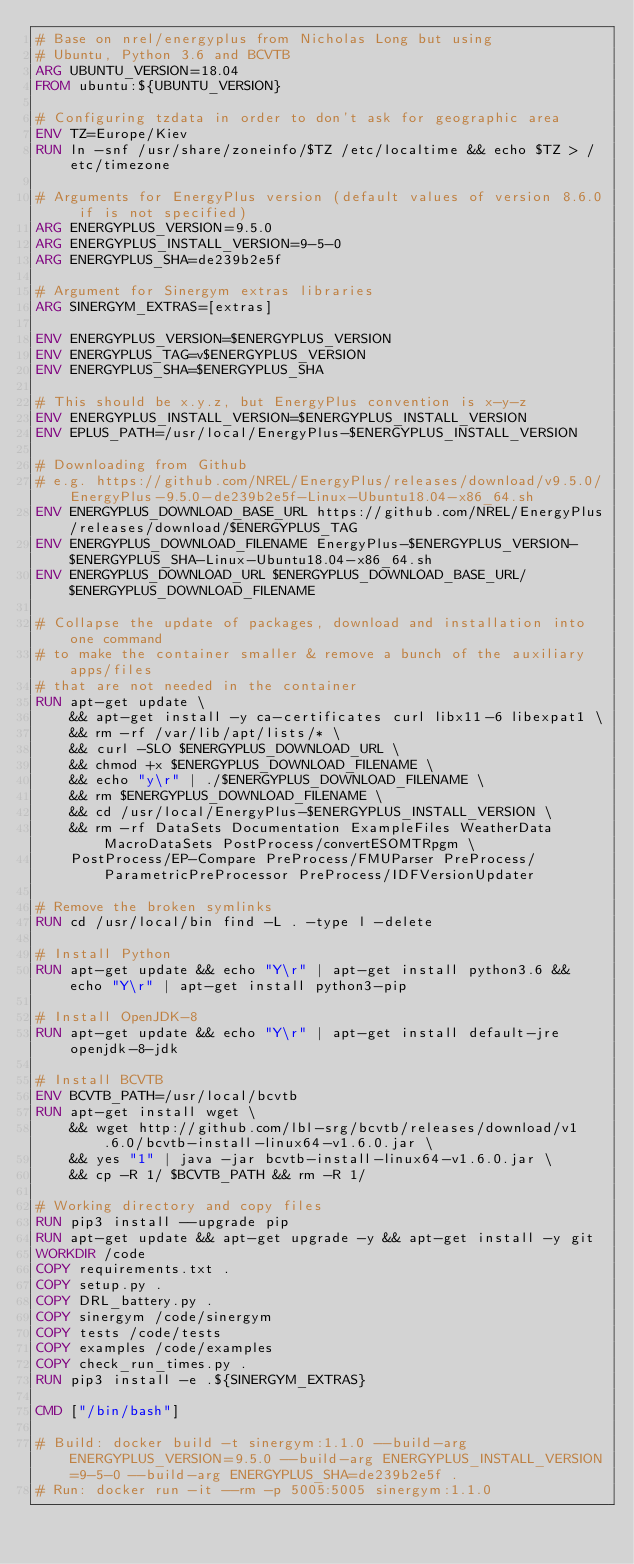Convert code to text. <code><loc_0><loc_0><loc_500><loc_500><_Dockerfile_># Base on nrel/energyplus from Nicholas Long but using 
# Ubuntu, Python 3.6 and BCVTB
ARG UBUNTU_VERSION=18.04
FROM ubuntu:${UBUNTU_VERSION}

# Configuring tzdata in order to don't ask for geographic area
ENV TZ=Europe/Kiev
RUN ln -snf /usr/share/zoneinfo/$TZ /etc/localtime && echo $TZ > /etc/timezone

# Arguments for EnergyPlus version (default values of version 8.6.0 if is not specified)
ARG ENERGYPLUS_VERSION=9.5.0
ARG ENERGYPLUS_INSTALL_VERSION=9-5-0
ARG ENERGYPLUS_SHA=de239b2e5f

# Argument for Sinergym extras libraries
ARG SINERGYM_EXTRAS=[extras]

ENV ENERGYPLUS_VERSION=$ENERGYPLUS_VERSION
ENV ENERGYPLUS_TAG=v$ENERGYPLUS_VERSION
ENV ENERGYPLUS_SHA=$ENERGYPLUS_SHA

# This should be x.y.z, but EnergyPlus convention is x-y-z
ENV ENERGYPLUS_INSTALL_VERSION=$ENERGYPLUS_INSTALL_VERSION
ENV EPLUS_PATH=/usr/local/EnergyPlus-$ENERGYPLUS_INSTALL_VERSION

# Downloading from Github
# e.g. https://github.com/NREL/EnergyPlus/releases/download/v9.5.0/EnergyPlus-9.5.0-de239b2e5f-Linux-Ubuntu18.04-x86_64.sh
ENV ENERGYPLUS_DOWNLOAD_BASE_URL https://github.com/NREL/EnergyPlus/releases/download/$ENERGYPLUS_TAG
ENV ENERGYPLUS_DOWNLOAD_FILENAME EnergyPlus-$ENERGYPLUS_VERSION-$ENERGYPLUS_SHA-Linux-Ubuntu18.04-x86_64.sh
ENV ENERGYPLUS_DOWNLOAD_URL $ENERGYPLUS_DOWNLOAD_BASE_URL/$ENERGYPLUS_DOWNLOAD_FILENAME

# Collapse the update of packages, download and installation into one command
# to make the container smaller & remove a bunch of the auxiliary apps/files
# that are not needed in the container
RUN apt-get update \
    && apt-get install -y ca-certificates curl libx11-6 libexpat1 \
    && rm -rf /var/lib/apt/lists/* \
    && curl -SLO $ENERGYPLUS_DOWNLOAD_URL \
    && chmod +x $ENERGYPLUS_DOWNLOAD_FILENAME \
    && echo "y\r" | ./$ENERGYPLUS_DOWNLOAD_FILENAME \
    && rm $ENERGYPLUS_DOWNLOAD_FILENAME \
    && cd /usr/local/EnergyPlus-$ENERGYPLUS_INSTALL_VERSION \
    && rm -rf DataSets Documentation ExampleFiles WeatherData MacroDataSets PostProcess/convertESOMTRpgm \
    PostProcess/EP-Compare PreProcess/FMUParser PreProcess/ParametricPreProcessor PreProcess/IDFVersionUpdater

# Remove the broken symlinks
RUN cd /usr/local/bin find -L . -type l -delete

# Install Python
RUN apt-get update && echo "Y\r" | apt-get install python3.6 && echo "Y\r" | apt-get install python3-pip

# Install OpenJDK-8
RUN apt-get update && echo "Y\r" | apt-get install default-jre openjdk-8-jdk

# Install BCVTB
ENV BCVTB_PATH=/usr/local/bcvtb
RUN apt-get install wget \
    && wget http://github.com/lbl-srg/bcvtb/releases/download/v1.6.0/bcvtb-install-linux64-v1.6.0.jar \
    && yes "1" | java -jar bcvtb-install-linux64-v1.6.0.jar \
    && cp -R 1/ $BCVTB_PATH && rm -R 1/

# Working directory and copy files
RUN pip3 install --upgrade pip
RUN apt-get update && apt-get upgrade -y && apt-get install -y git
WORKDIR /code
COPY requirements.txt .
COPY setup.py .
COPY DRL_battery.py .
COPY sinergym /code/sinergym
COPY tests /code/tests
COPY examples /code/examples
COPY check_run_times.py .
RUN pip3 install -e .${SINERGYM_EXTRAS}

CMD ["/bin/bash"]

# Build: docker build -t sinergym:1.1.0 --build-arg ENERGYPLUS_VERSION=9.5.0 --build-arg ENERGYPLUS_INSTALL_VERSION=9-5-0 --build-arg ENERGYPLUS_SHA=de239b2e5f .
# Run: docker run -it --rm -p 5005:5005 sinergym:1.1.0</code> 